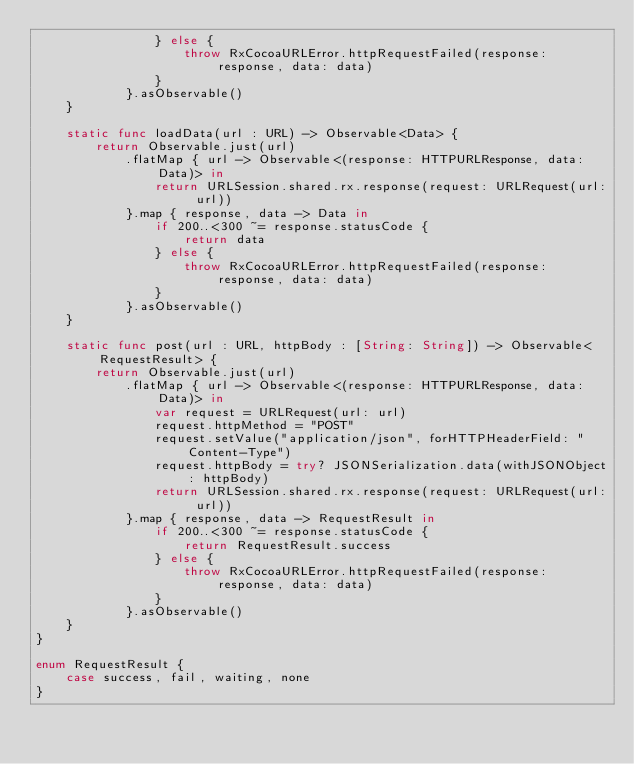<code> <loc_0><loc_0><loc_500><loc_500><_Swift_>                } else {
                    throw RxCocoaURLError.httpRequestFailed(response: response, data: data)
                }
            }.asObservable()
    }
    
    static func loadData(url : URL) -> Observable<Data> {
        return Observable.just(url)
            .flatMap { url -> Observable<(response: HTTPURLResponse, data: Data)> in
                return URLSession.shared.rx.response(request: URLRequest(url: url))
            }.map { response, data -> Data in
                if 200..<300 ~= response.statusCode {
                    return data
                } else {
                    throw RxCocoaURLError.httpRequestFailed(response: response, data: data)
                }
            }.asObservable()
    }
    
    static func post(url : URL, httpBody : [String: String]) -> Observable<RequestResult> {
        return Observable.just(url)
            .flatMap { url -> Observable<(response: HTTPURLResponse, data: Data)> in
                var request = URLRequest(url: url)
                request.httpMethod = "POST"
                request.setValue("application/json", forHTTPHeaderField: "Content-Type")
                request.httpBody = try? JSONSerialization.data(withJSONObject: httpBody)
                return URLSession.shared.rx.response(request: URLRequest(url: url))
            }.map { response, data -> RequestResult in
                if 200..<300 ~= response.statusCode {
                    return RequestResult.success
                } else {
                    throw RxCocoaURLError.httpRequestFailed(response: response, data: data)
                }
            }.asObservable()
    }
}

enum RequestResult {
    case success, fail, waiting, none
}
</code> 